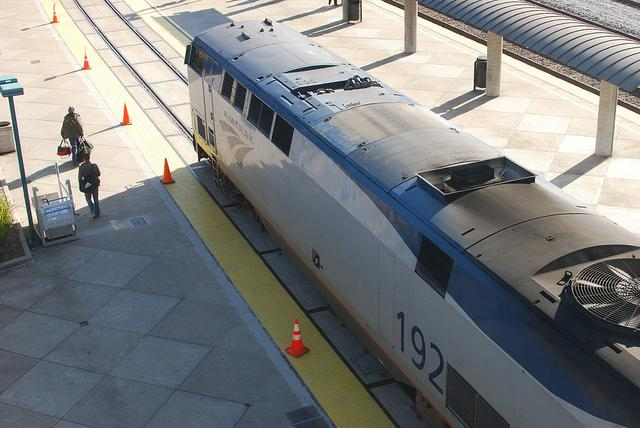What is the sum of the three digits on the train? Please explain your reasoning. 12. The sum of the number 1, 9 and 2 would be 12. 